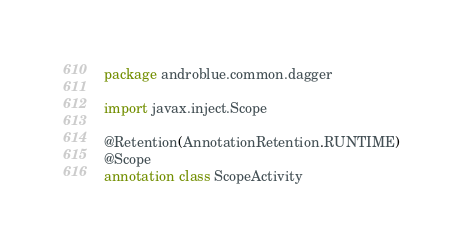Convert code to text. <code><loc_0><loc_0><loc_500><loc_500><_Kotlin_>package androblue.common.dagger

import javax.inject.Scope

@Retention(AnnotationRetention.RUNTIME)
@Scope
annotation class ScopeActivity
</code> 